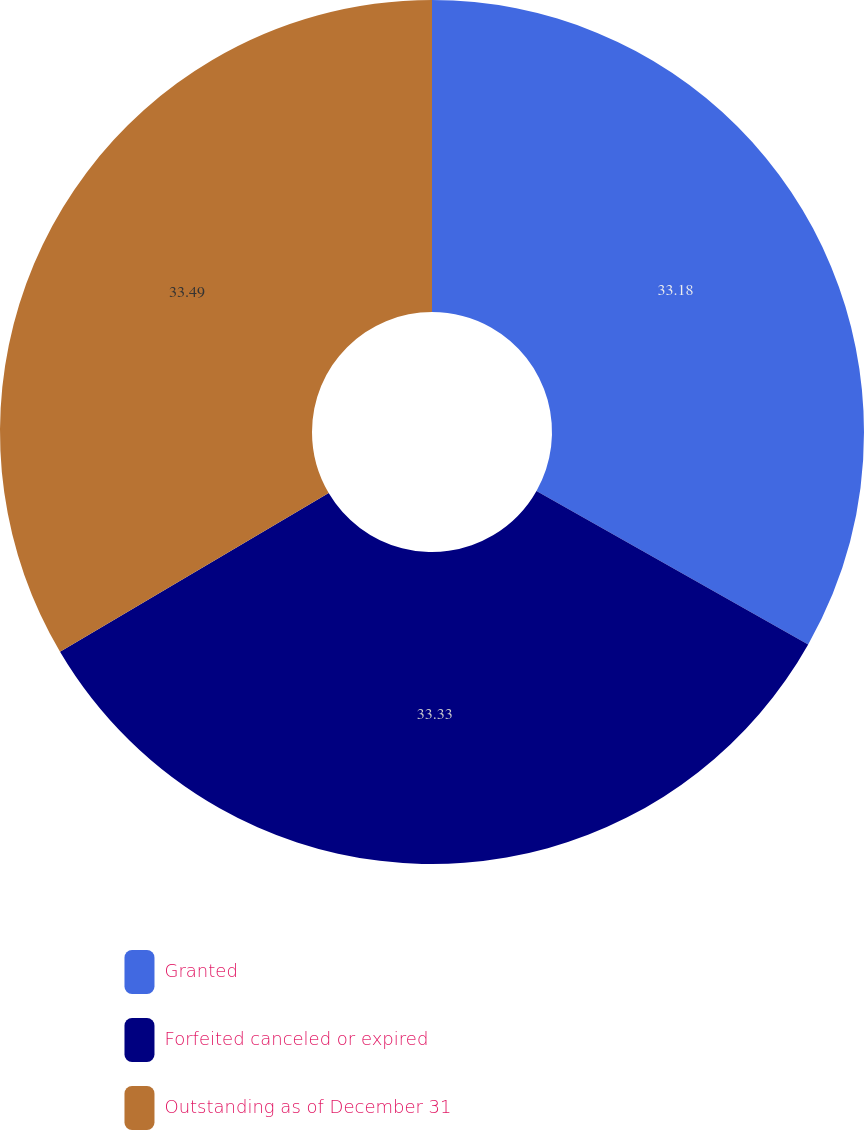Convert chart. <chart><loc_0><loc_0><loc_500><loc_500><pie_chart><fcel>Granted<fcel>Forfeited canceled or expired<fcel>Outstanding as of December 31<nl><fcel>33.18%<fcel>33.33%<fcel>33.49%<nl></chart> 